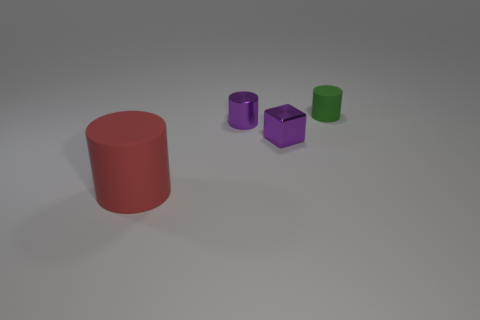What number of other objects have the same shape as the small green object?
Your answer should be compact. 2. What size is the green object that is made of the same material as the red cylinder?
Provide a succinct answer. Small. What is the object that is both left of the tiny block and in front of the tiny metallic cylinder made of?
Provide a succinct answer. Rubber. How many other red rubber cylinders are the same size as the red rubber cylinder?
Keep it short and to the point. 0. There is a tiny purple object that is the same shape as the red object; what is its material?
Provide a succinct answer. Metal. What number of things are tiny metallic objects behind the cube or objects that are on the right side of the red thing?
Provide a succinct answer. 3. Does the green thing have the same shape as the rubber object that is in front of the small green matte thing?
Offer a very short reply. Yes. There is a matte object that is in front of the tiny cylinder left of the rubber cylinder that is behind the big rubber cylinder; what shape is it?
Provide a short and direct response. Cylinder. What number of other objects are there of the same material as the large red object?
Ensure brevity in your answer.  1. How many things are small metal things that are behind the shiny block or cyan matte cylinders?
Keep it short and to the point. 1. 